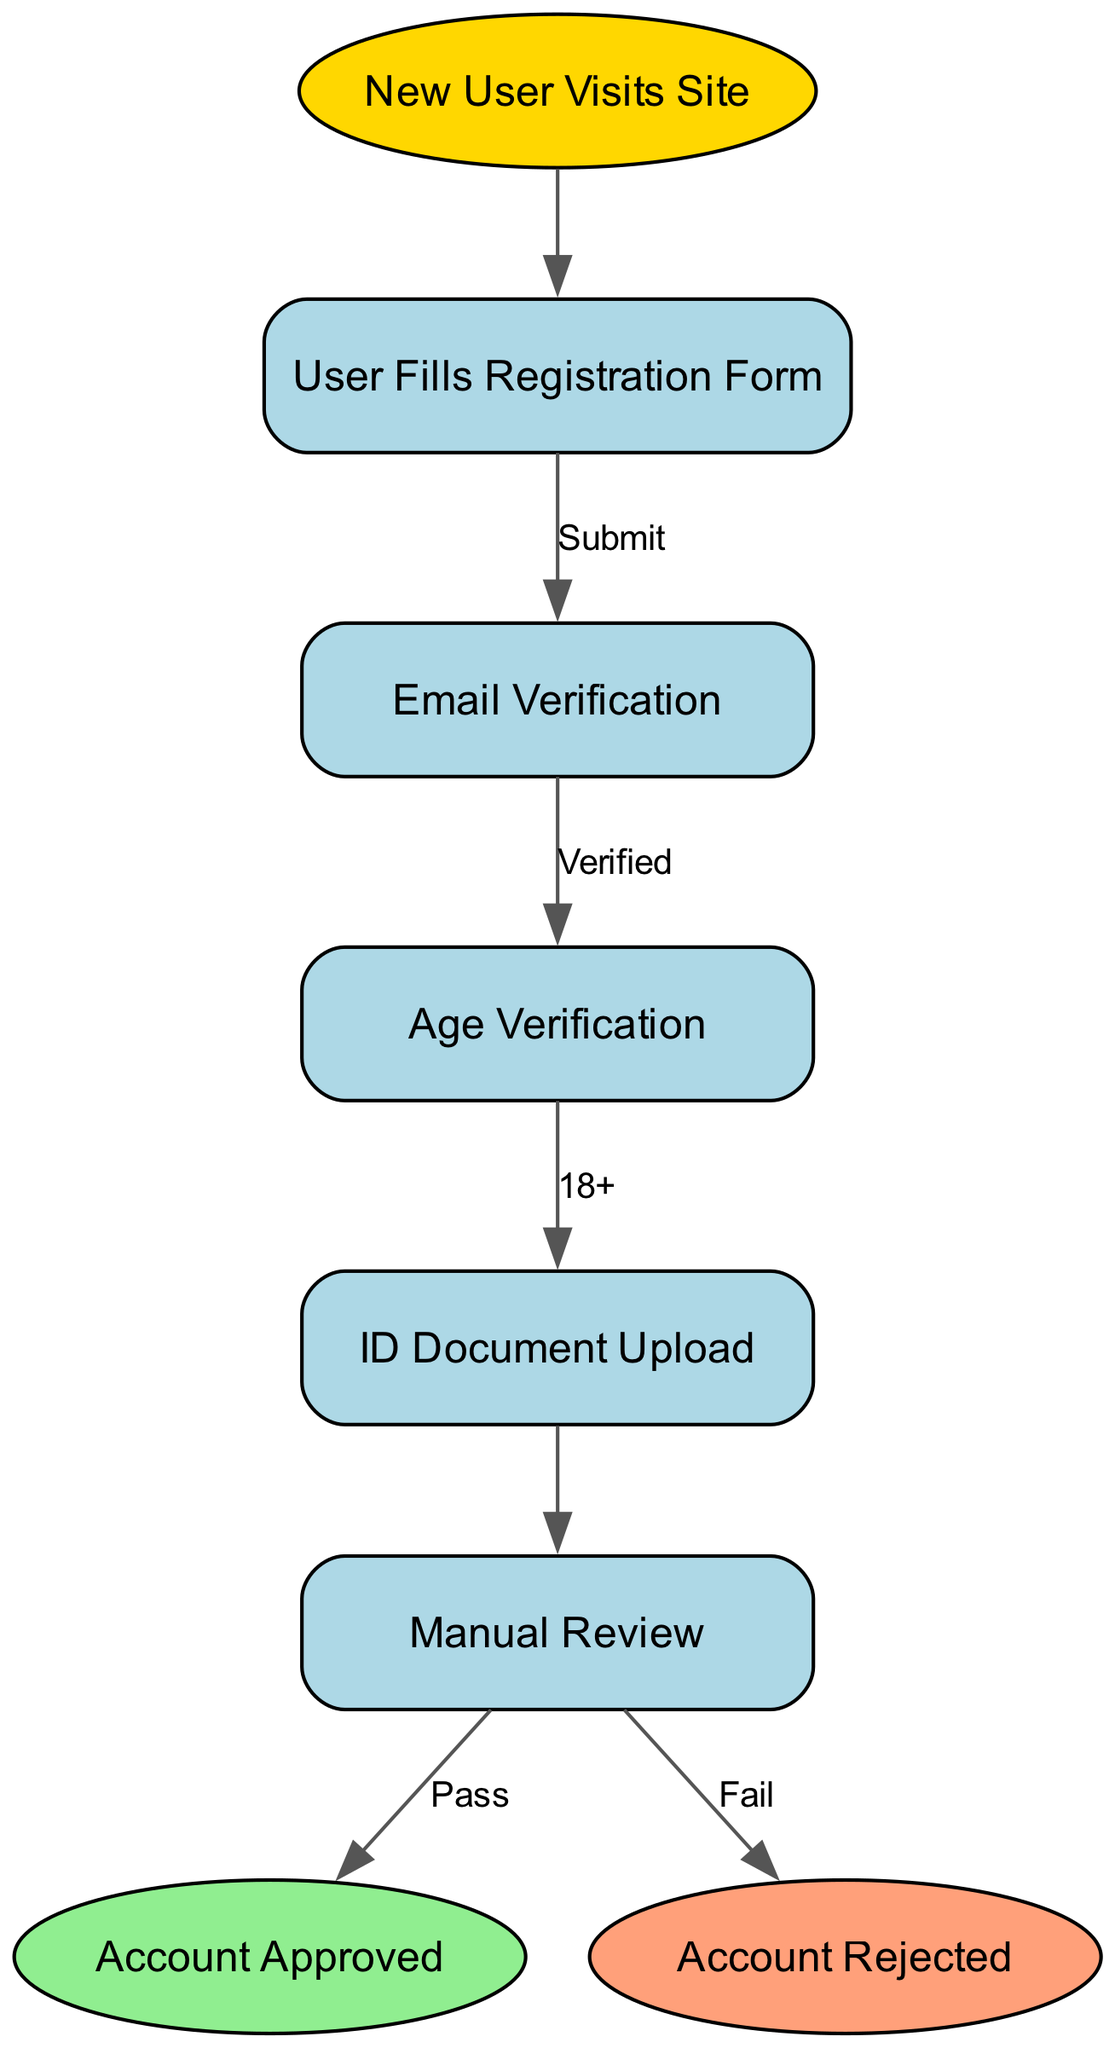What is the first step in the customer registration process? The first step in the process is represented by the node "New User Visits Site." This node initiates the flow of the registration process.
Answer: New User Visits Site How many nodes are in the diagram? The diagram contains a total of eight nodes, each representing a distinct step or state in the customer registration and verification process.
Answer: 8 What happens after the user fills out the registration form? After the user fills out the registration form, the flow moves to "Email Verification," showing that email verification is a necessary step following registration.
Answer: Email Verification What are the outcomes of the manual review? The manual review can lead to two outcomes: "Account Approved" or "Account Rejected," indicating the final status of the registration process based on the review outcome.
Answer: Account Approved, Account Rejected What is the minimum age requirement for registration? The diagram includes a step for "Age Verification," which specifies that users must be "18+" to continue with the registration process, denoting the minimum age requirement.
Answer: 18+ What is the color indicating the starting point of the process? The starting point, represented by "New User Visits Site," is colored gold (FFD700) in the diagram, indicating its role as the origin of the flow.
Answer: Gold What step occurs immediately after age verification? Immediately following age verification, the user is required to upload an ID document, as shown by the flow moving to the "ID Document Upload" step.
Answer: ID Document Upload If a user's account fails the manual review, what node do they reach? If the account fails the manual review, the flow directs them to the "Account Rejected" node, signifying the conclusion of their registration attempt with a rejection status.
Answer: Account Rejected 